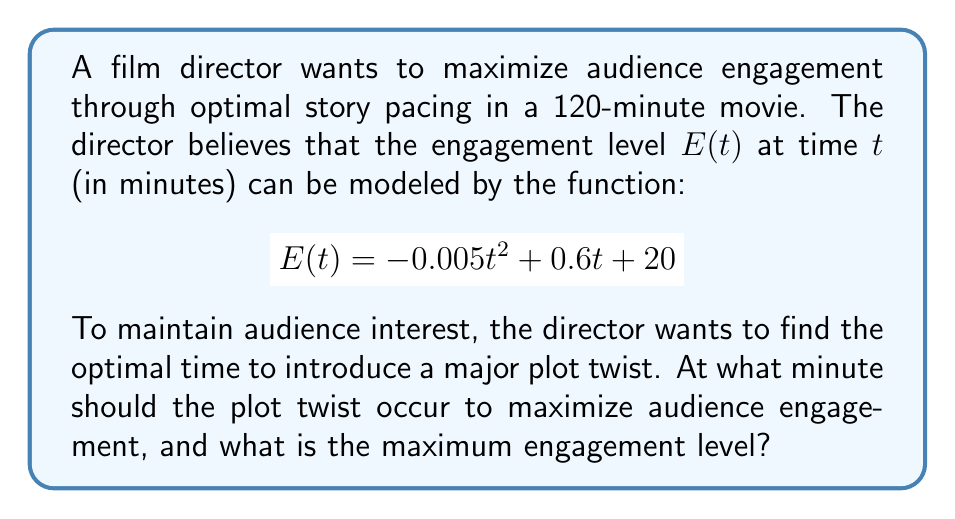Can you answer this question? To solve this optimization problem, we need to follow these steps:

1. Identify the function to be maximized:
   $$E(t) = -0.005t^2 + 0.6t + 20$$

2. Find the derivative of the function:
   $$E'(t) = -0.01t + 0.6$$

3. Set the derivative equal to zero and solve for t:
   $$-0.01t + 0.6 = 0$$
   $$-0.01t = -0.6$$
   $$t = 60$$

4. Verify that this critical point is a maximum by checking the second derivative:
   $$E''(t) = -0.01$$
   Since $E''(t)$ is negative, the critical point is indeed a maximum.

5. Calculate the maximum engagement level by plugging t = 60 into the original function:
   $$E(60) = -0.005(60)^2 + 0.6(60) + 20$$
   $$= -18 + 36 + 20$$
   $$= 38$$

Therefore, the optimal time to introduce the major plot twist is at the 60-minute mark, which is exactly halfway through the 120-minute movie. This timing creates a perfect balance in the story structure, aligning with classic storytelling techniques like the midpoint reversal.

The maximum engagement level at this point is 38, which represents the peak of audience interest and involvement in the story.
Answer: The optimal time to introduce the major plot twist is at the 60-minute mark, and the maximum engagement level is 38. 